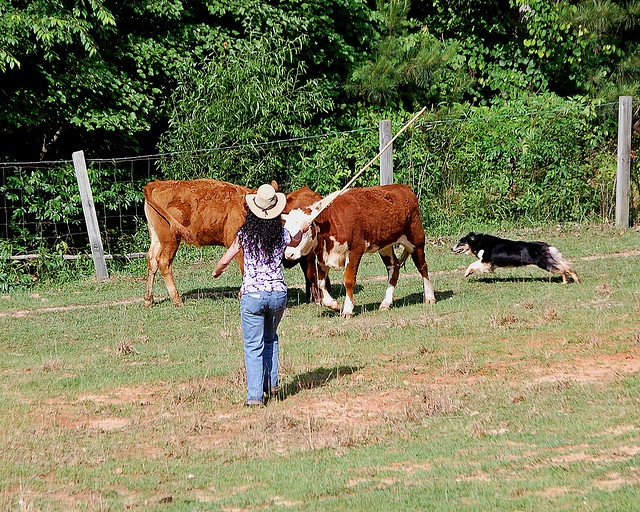Describe the objects in this image and their specific colors. I can see cow in darkgreen, maroon, brown, black, and white tones, people in darkgreen, black, lightgray, darkgray, and navy tones, cow in darkgreen, brown, tan, and maroon tones, dog in darkgreen, black, lightgray, gray, and tan tones, and cow in darkgreen, black, brown, maroon, and salmon tones in this image. 